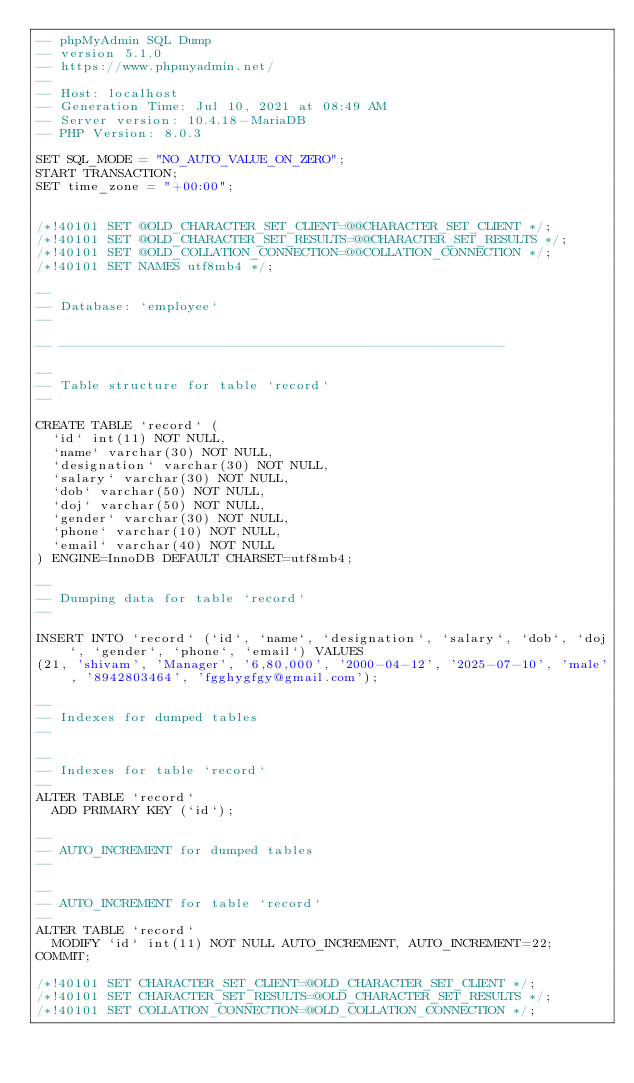Convert code to text. <code><loc_0><loc_0><loc_500><loc_500><_SQL_>-- phpMyAdmin SQL Dump
-- version 5.1.0
-- https://www.phpmyadmin.net/
--
-- Host: localhost
-- Generation Time: Jul 10, 2021 at 08:49 AM
-- Server version: 10.4.18-MariaDB
-- PHP Version: 8.0.3

SET SQL_MODE = "NO_AUTO_VALUE_ON_ZERO";
START TRANSACTION;
SET time_zone = "+00:00";


/*!40101 SET @OLD_CHARACTER_SET_CLIENT=@@CHARACTER_SET_CLIENT */;
/*!40101 SET @OLD_CHARACTER_SET_RESULTS=@@CHARACTER_SET_RESULTS */;
/*!40101 SET @OLD_COLLATION_CONNECTION=@@COLLATION_CONNECTION */;
/*!40101 SET NAMES utf8mb4 */;

--
-- Database: `employee`
--

-- --------------------------------------------------------

--
-- Table structure for table `record`
--

CREATE TABLE `record` (
  `id` int(11) NOT NULL,
  `name` varchar(30) NOT NULL,
  `designation` varchar(30) NOT NULL,
  `salary` varchar(30) NOT NULL,
  `dob` varchar(50) NOT NULL,
  `doj` varchar(50) NOT NULL,
  `gender` varchar(30) NOT NULL,
  `phone` varchar(10) NOT NULL,
  `email` varchar(40) NOT NULL
) ENGINE=InnoDB DEFAULT CHARSET=utf8mb4;

--
-- Dumping data for table `record`
--

INSERT INTO `record` (`id`, `name`, `designation`, `salary`, `dob`, `doj`, `gender`, `phone`, `email`) VALUES
(21, 'shivam', 'Manager', '6,80,000', '2000-04-12', '2025-07-10', 'male', '8942803464', 'fgghygfgy@gmail.com');

--
-- Indexes for dumped tables
--

--
-- Indexes for table `record`
--
ALTER TABLE `record`
  ADD PRIMARY KEY (`id`);

--
-- AUTO_INCREMENT for dumped tables
--

--
-- AUTO_INCREMENT for table `record`
--
ALTER TABLE `record`
  MODIFY `id` int(11) NOT NULL AUTO_INCREMENT, AUTO_INCREMENT=22;
COMMIT;

/*!40101 SET CHARACTER_SET_CLIENT=@OLD_CHARACTER_SET_CLIENT */;
/*!40101 SET CHARACTER_SET_RESULTS=@OLD_CHARACTER_SET_RESULTS */;
/*!40101 SET COLLATION_CONNECTION=@OLD_COLLATION_CONNECTION */;
</code> 